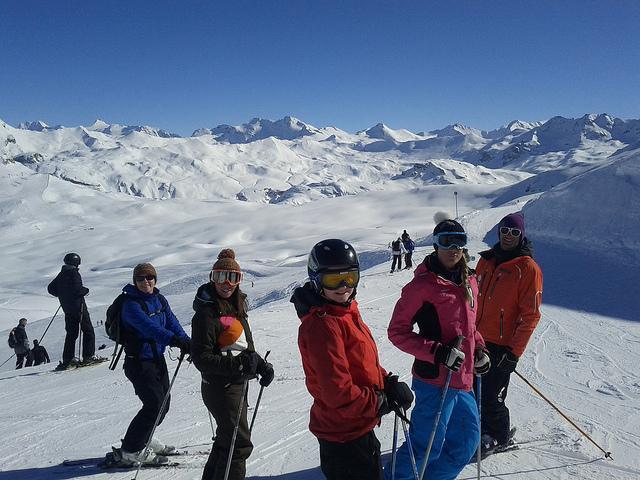How many people face the camera?
Give a very brief answer. 5. How many people are wearing yellow ski pants?
Give a very brief answer. 0. How many people are there?
Give a very brief answer. 10. How many ski slopes are there?
Give a very brief answer. 1. How many people have their eyes covered?
Give a very brief answer. 5. How many people can be seen?
Give a very brief answer. 6. 